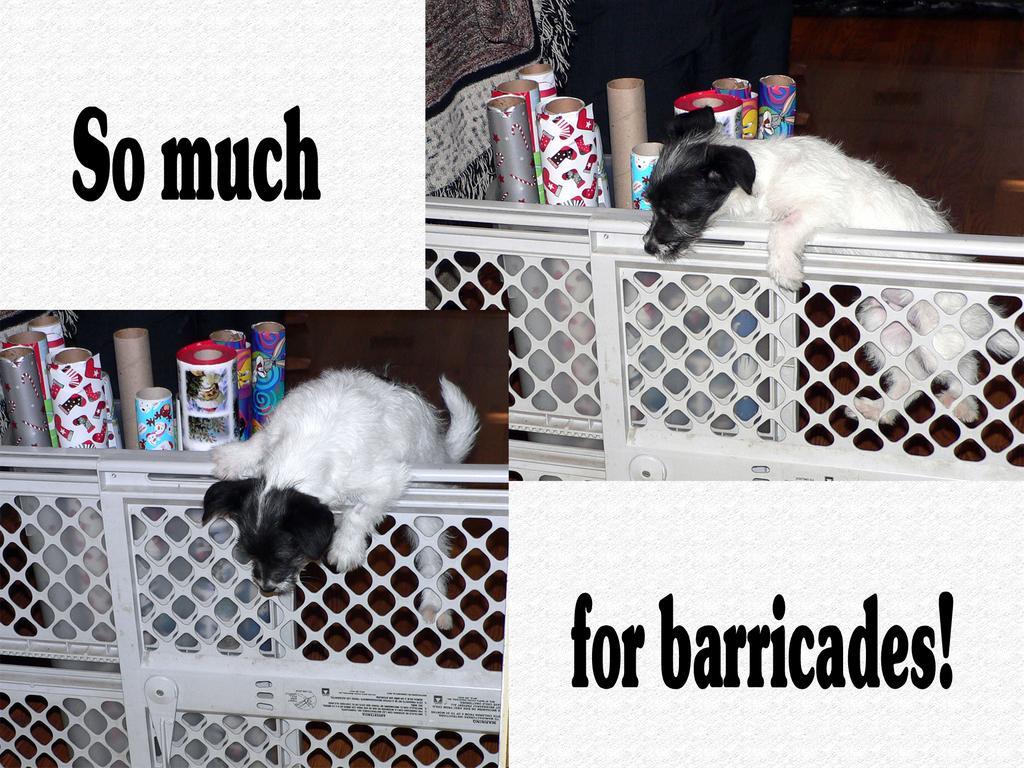Please provide a concise description of this image. In this image we can see dogs on the fence, there are some objects and text on the white color board, also we can see a cloth. 